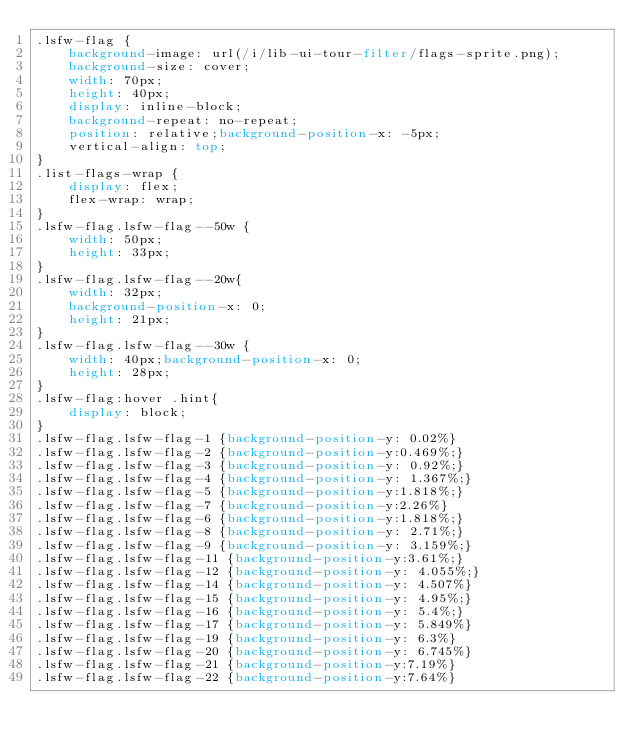Convert code to text. <code><loc_0><loc_0><loc_500><loc_500><_CSS_>.lsfw-flag {
    background-image: url(/i/lib-ui-tour-filter/flags-sprite.png);
    background-size: cover;
    width: 70px;
    height: 40px;
    display: inline-block;
    background-repeat: no-repeat;
    position: relative;background-position-x: -5px;
    vertical-align: top;
}
.list-flags-wrap {
    display: flex;
    flex-wrap: wrap;
}
.lsfw-flag.lsfw-flag--50w {
    width: 50px;
    height: 33px;
}
.lsfw-flag.lsfw-flag--20w{
    width: 32px;
    background-position-x: 0;
    height: 21px;
}
.lsfw-flag.lsfw-flag--30w {
    width: 40px;background-position-x: 0;
    height: 28px;
}
.lsfw-flag:hover .hint{
    display: block;
}
.lsfw-flag.lsfw-flag-1 {background-position-y: 0.02%}
.lsfw-flag.lsfw-flag-2 {background-position-y:0.469%;}
.lsfw-flag.lsfw-flag-3 {background-position-y: 0.92%;}
.lsfw-flag.lsfw-flag-4 {background-position-y: 1.367%;}
.lsfw-flag.lsfw-flag-5 {background-position-y:1.818%;}
.lsfw-flag.lsfw-flag-7 {background-position-y:2.26%}
.lsfw-flag.lsfw-flag-6 {background-position-y:1.818%;}
.lsfw-flag.lsfw-flag-8 {background-position-y: 2.71%;}
.lsfw-flag.lsfw-flag-9 {background-position-y: 3.159%;}
.lsfw-flag.lsfw-flag-11 {background-position-y:3.61%;}
.lsfw-flag.lsfw-flag-12 {background-position-y: 4.055%;}
.lsfw-flag.lsfw-flag-14 {background-position-y: 4.507%}
.lsfw-flag.lsfw-flag-15 {background-position-y: 4.95%;}
.lsfw-flag.lsfw-flag-16 {background-position-y: 5.4%;}
.lsfw-flag.lsfw-flag-17 {background-position-y: 5.849%}
.lsfw-flag.lsfw-flag-19 {background-position-y: 6.3%}
.lsfw-flag.lsfw-flag-20 {background-position-y: 6.745%}
.lsfw-flag.lsfw-flag-21 {background-position-y:7.19%}
.lsfw-flag.lsfw-flag-22 {background-position-y:7.64%}</code> 